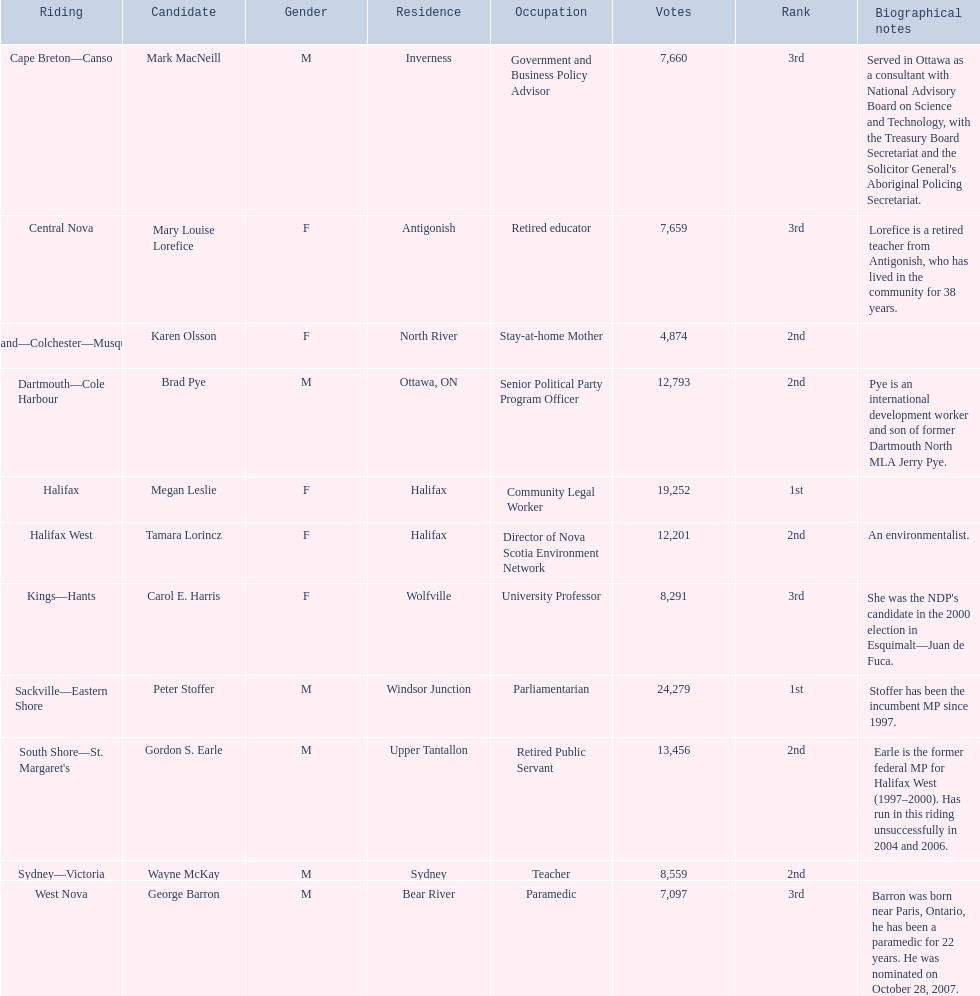How many votes did macneill receive? 7,660. How many votes did olsoon receive? 4,874. Between macneil and olsson, who received more votes? Mark MacNeill. 